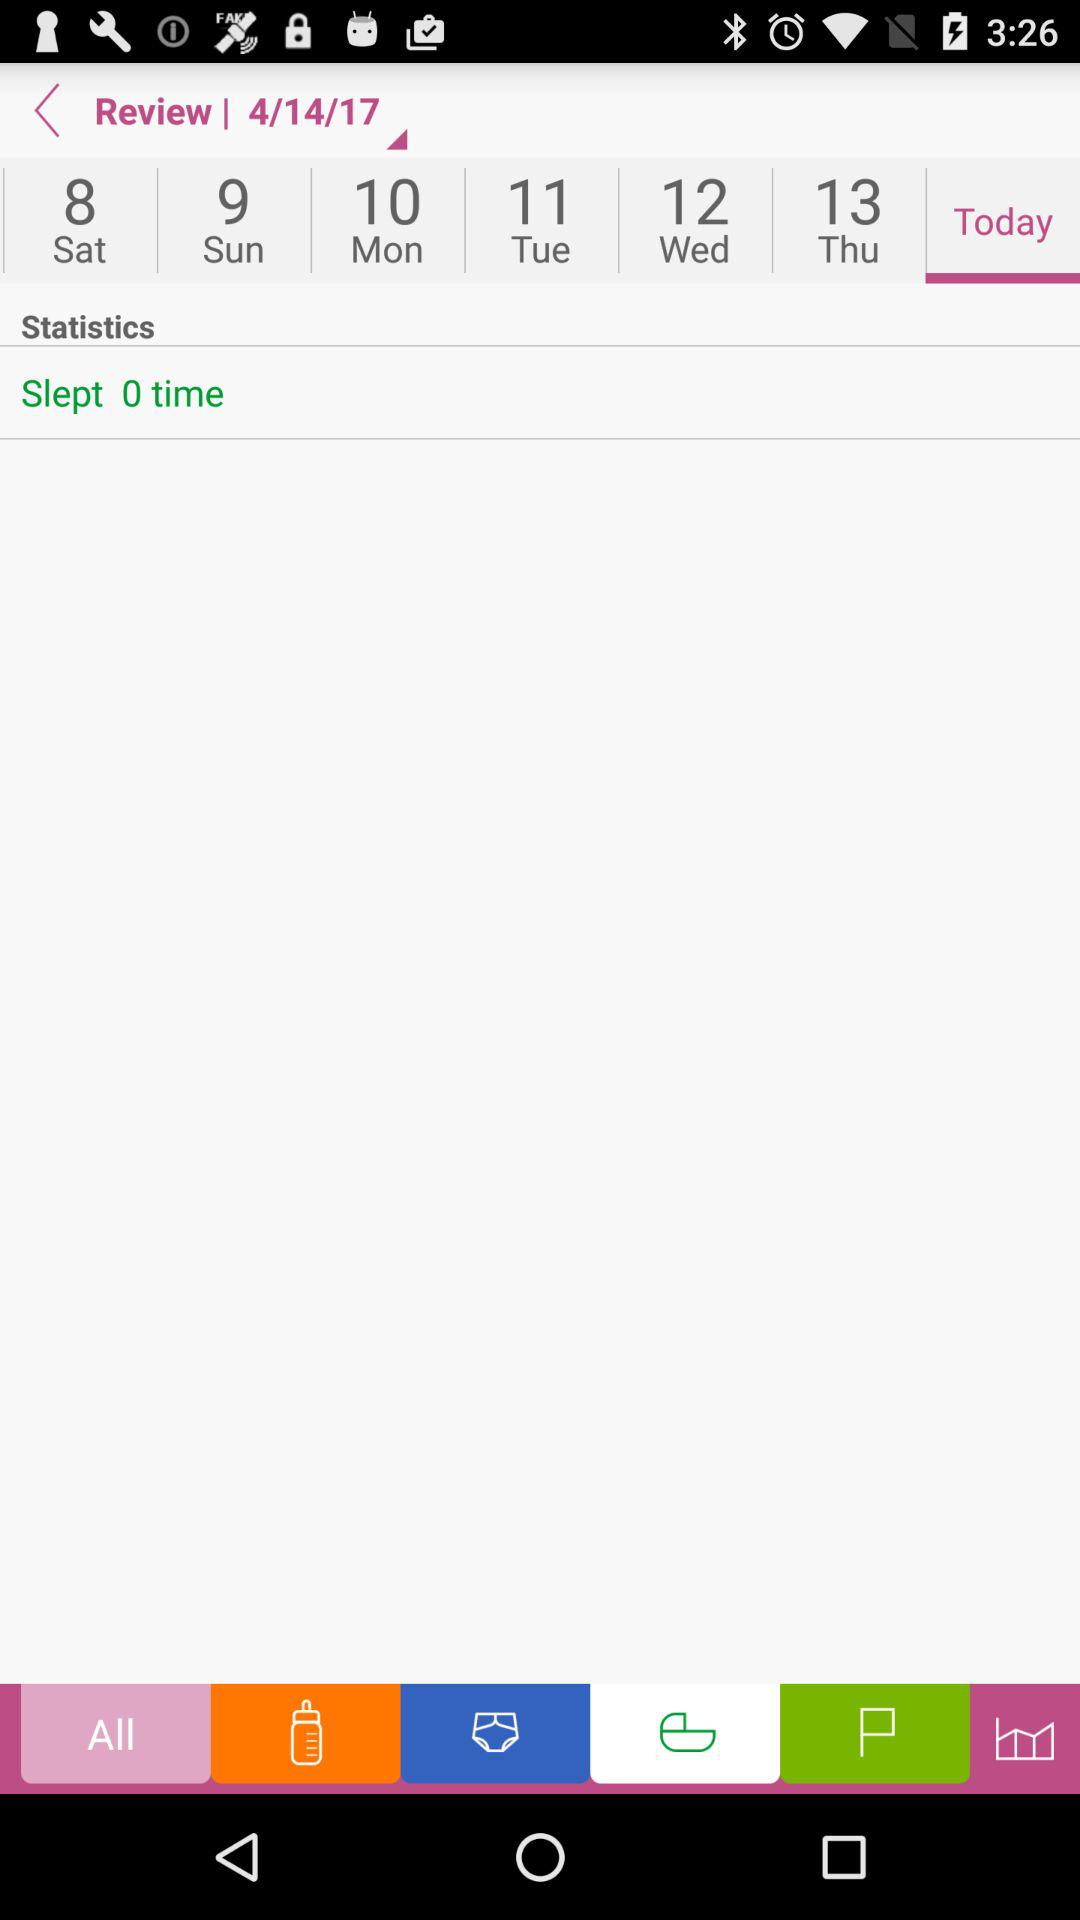Which day is April 12th? The day is Wednesday. 